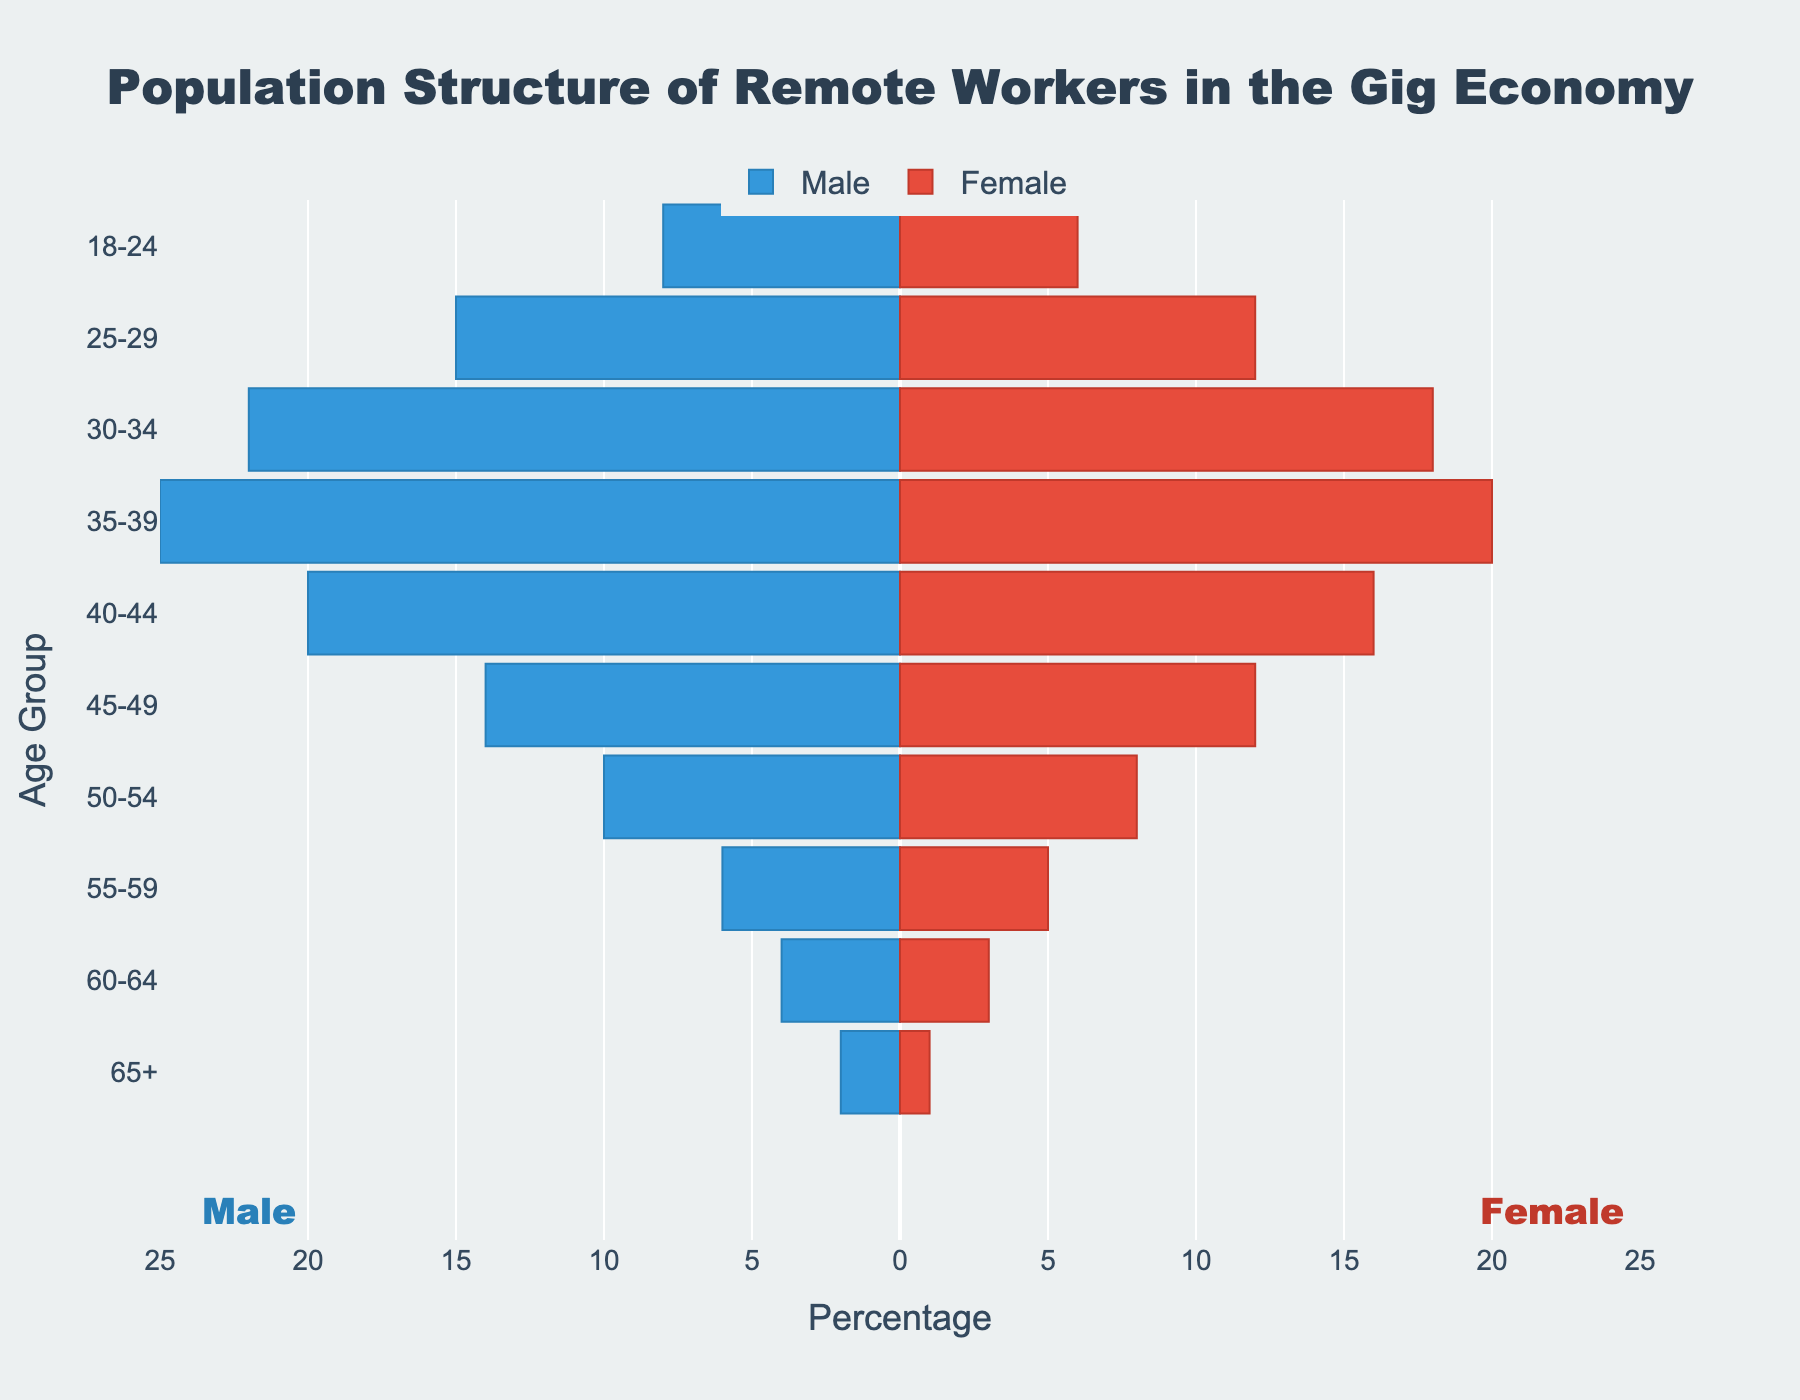What age group has the highest number of male remote workers? Look at the length of the bars on the left side, which represent male workers. The age group 35-39 has the longest bar.
Answer: 35-39 What is the total number of female remote workers in the age group 30-34? The bar representing females in the age group 30-34 is 18.
Answer: 18 By how much does the number of male remote workers in the age group 35-39 exceed that of females in the same age group? The number for males is 25 and for females it is 20. The difference is 25 - 20.
Answer: 5 Which gender has more remote workers in the age group 18-24? Compare the length of bars in the age group 18-24. The male bar (with a value of 8) is longer than the female bar (with a value of 6).
Answer: Male What is the combined total number of remote workers (both male and female) in the age group 40-44? Add the number of male workers (20) and female workers (16) in the age group 40-44.
Answer: 36 How does the number of female remote workers in the age group 55-59 compare to that in the age group 60-64? The bar for females in age group 55-59 is 5, and the bar for age group 60-64 is 3. Therefore, 5 is greater than 3.
Answer: Female workers in the 55-59 age group outnumber those in the 60-64 age group by 2 Which age group has the least number of total remote workers (both male and female)? The age group 65+ has the smallest values, with 2 males and 1 female, totaling 3.
Answer: 65+ How many more male remote workers are there compared to female remote workers in the age group 25-29? The number for males is 15 and for females it is 12. The difference is 15 - 12.
Answer: 3 What can you infer about the distribution of remote workers among the different age groups for both genders? The remote worker population peaks in the 35-39 age group for both genders, with a gradual decline in both directions (younger and older).
Answer: Highest population in the 35-39 age group, declining in both younger and older groups 